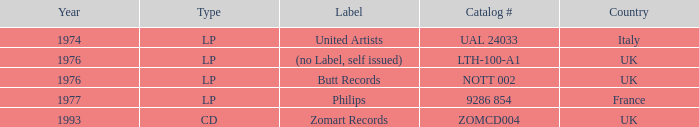What is the earliest year catalog # ual 24033 had an LP? 1974.0. 